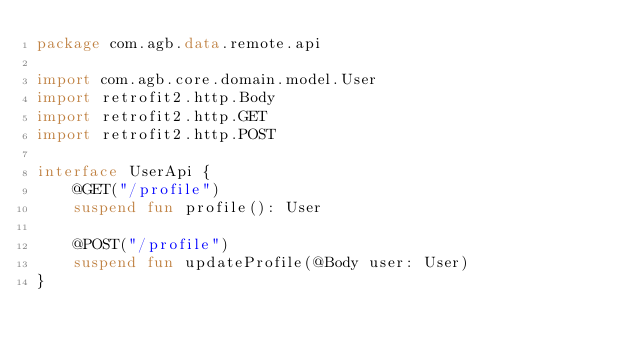Convert code to text. <code><loc_0><loc_0><loc_500><loc_500><_Kotlin_>package com.agb.data.remote.api

import com.agb.core.domain.model.User
import retrofit2.http.Body
import retrofit2.http.GET
import retrofit2.http.POST

interface UserApi {
    @GET("/profile")
    suspend fun profile(): User

    @POST("/profile")
    suspend fun updateProfile(@Body user: User)
}
</code> 